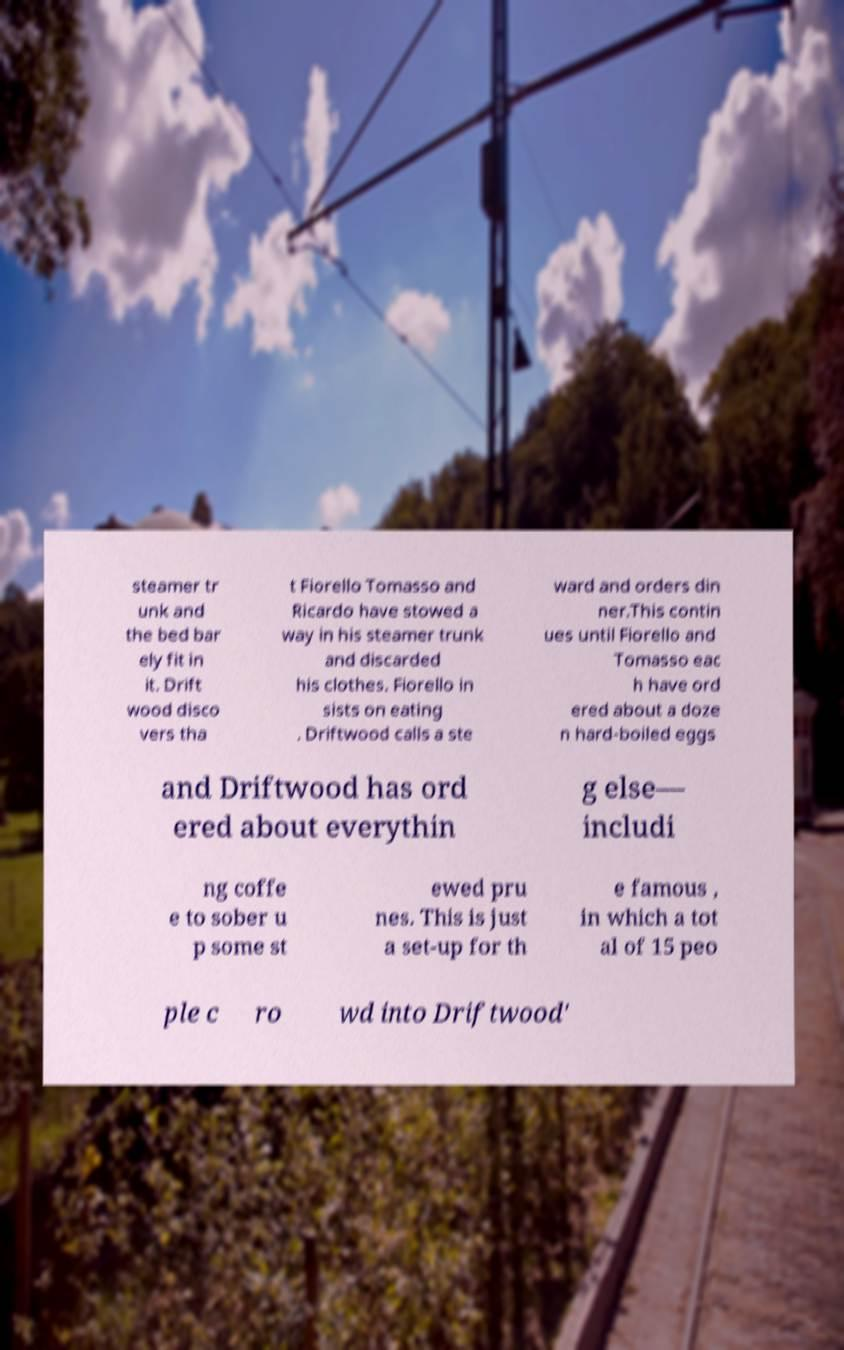For documentation purposes, I need the text within this image transcribed. Could you provide that? steamer tr unk and the bed bar ely fit in it. Drift wood disco vers tha t Fiorello Tomasso and Ricardo have stowed a way in his steamer trunk and discarded his clothes. Fiorello in sists on eating . Driftwood calls a ste ward and orders din ner.This contin ues until Fiorello and Tomasso eac h have ord ered about a doze n hard-boiled eggs and Driftwood has ord ered about everythin g else— includi ng coffe e to sober u p some st ewed pru nes. This is just a set-up for th e famous , in which a tot al of 15 peo ple c ro wd into Driftwood' 